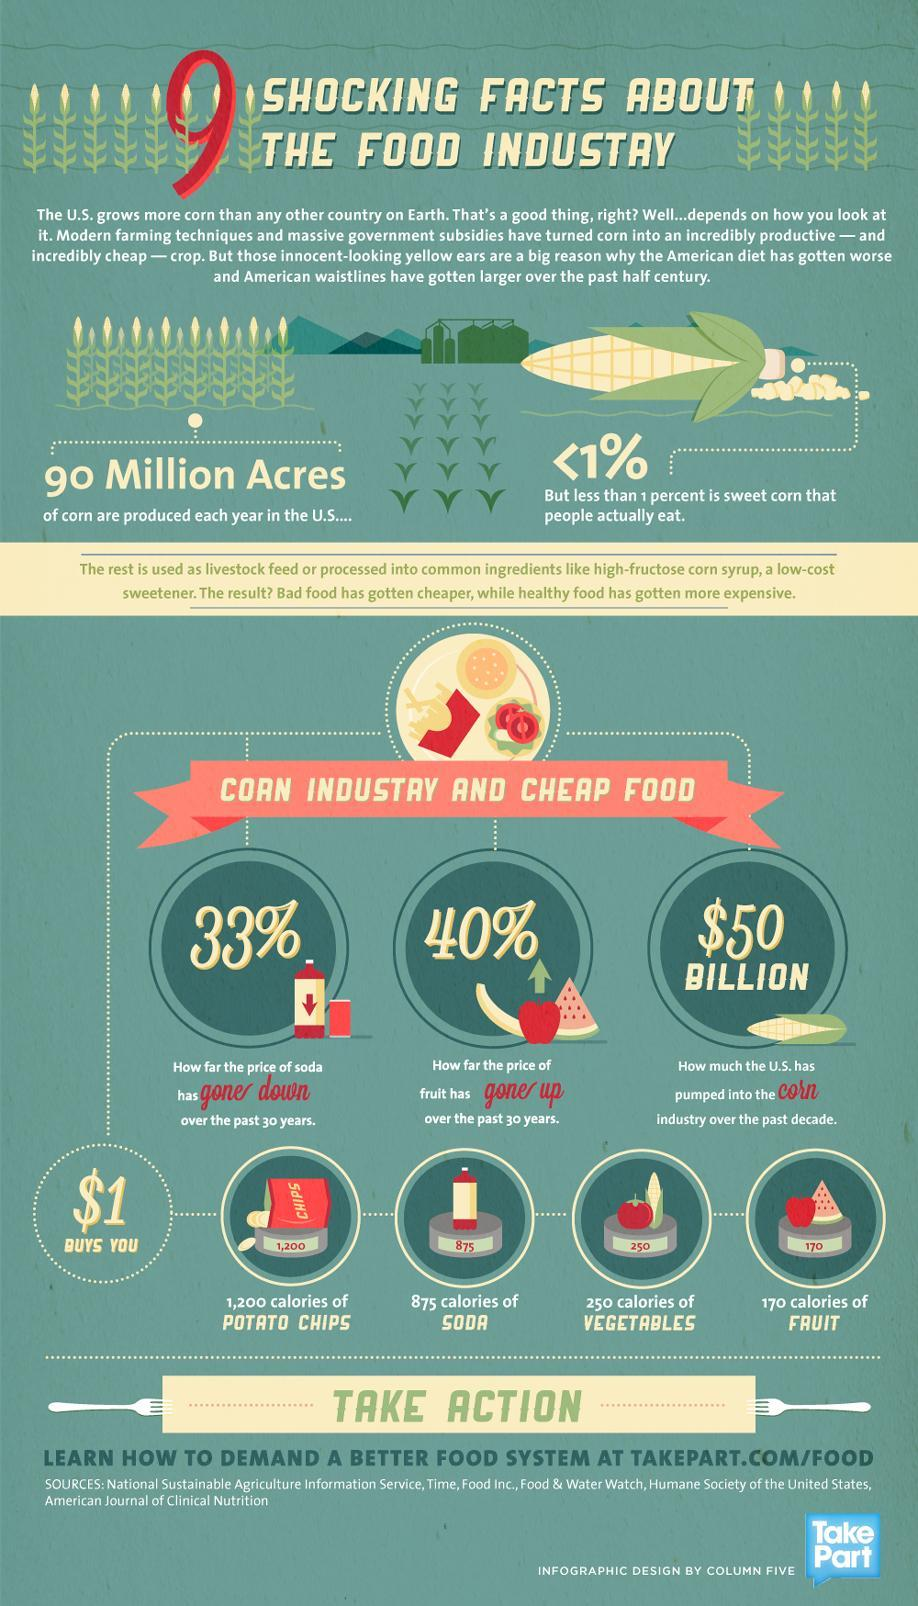What is the percentage decrease seen in the price of soda in the U.S. over the past 30 years?
Answer the question with a short phrase. 33% What is the percentage increase seen in the price of fruits in the U.S. over the past 30 years? 40% How much does the U.S. spend on the corn industry over the past decade? $50 BILLION 